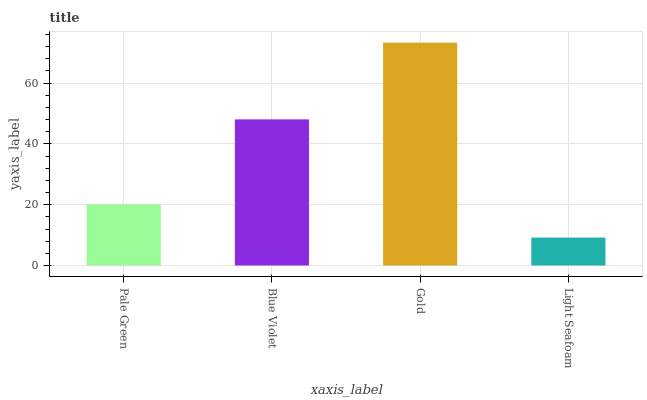Is Light Seafoam the minimum?
Answer yes or no. Yes. Is Gold the maximum?
Answer yes or no. Yes. Is Blue Violet the minimum?
Answer yes or no. No. Is Blue Violet the maximum?
Answer yes or no. No. Is Blue Violet greater than Pale Green?
Answer yes or no. Yes. Is Pale Green less than Blue Violet?
Answer yes or no. Yes. Is Pale Green greater than Blue Violet?
Answer yes or no. No. Is Blue Violet less than Pale Green?
Answer yes or no. No. Is Blue Violet the high median?
Answer yes or no. Yes. Is Pale Green the low median?
Answer yes or no. Yes. Is Light Seafoam the high median?
Answer yes or no. No. Is Blue Violet the low median?
Answer yes or no. No. 